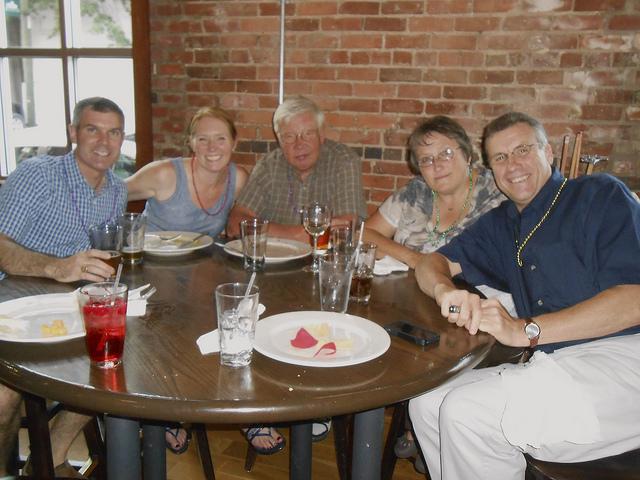Are both ladies wearing necklaces?
Write a very short answer. Yes. What is the wall made of?
Write a very short answer. Brick. What is the color of the brick?
Short answer required. Red. Are there any women at the table?
Short answer required. Yes. Are they related?
Be succinct. Yes. Is everyone smiling?
Keep it brief. No. Are any of these people married?
Write a very short answer. Yes. Did everyone eat the food?
Answer briefly. Yes. What drink is different than all the rest?
Answer briefly. Red one. 